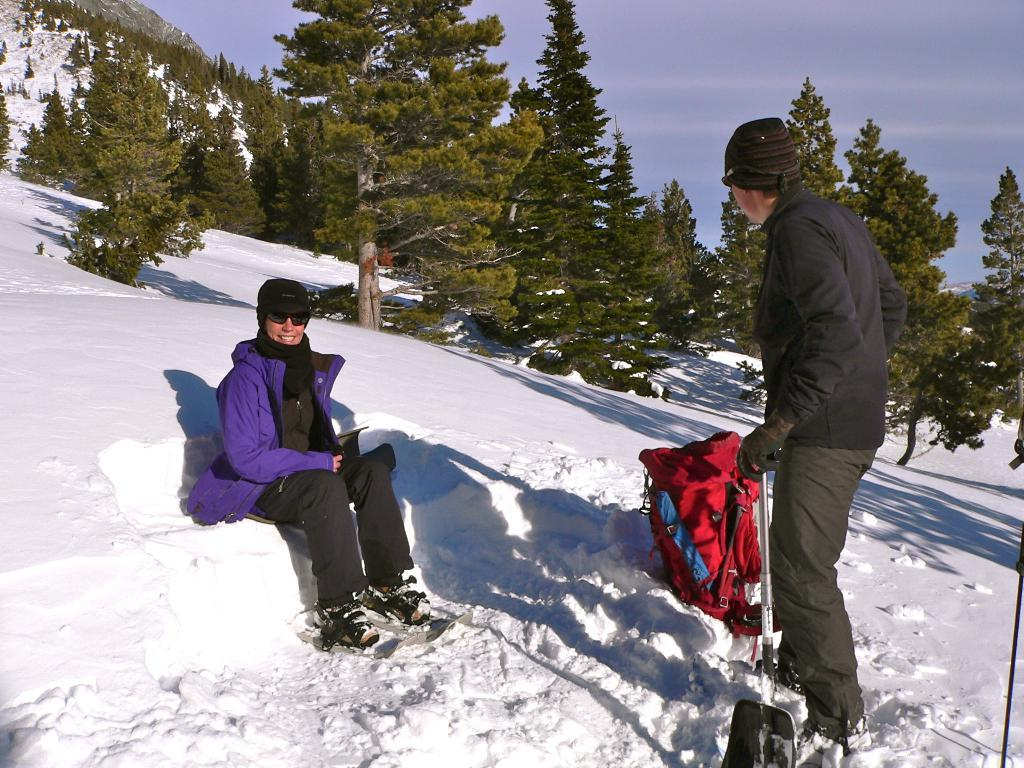What is the main subject of the image? There is a person in the image. What is the person doing in the image? The person is sitting and standing on the snow. What can be seen in the background of the image? There are hills, trees, and snow visible in the background of the image. What part of the natural environment is visible in the image? The sky is visible in the background of the image. How many tigers can be seen in the image? There are no tigers present in the image. What type of test is the person taking in the image? There is no test visible in the image; the person is simply sitting and standing on the snow. 